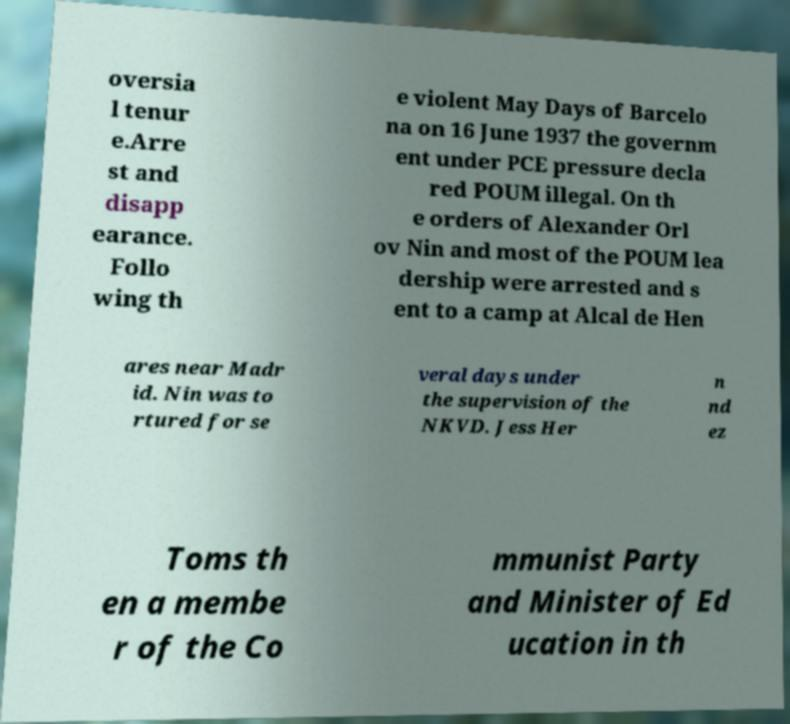Please identify and transcribe the text found in this image. oversia l tenur e.Arre st and disapp earance. Follo wing th e violent May Days of Barcelo na on 16 June 1937 the governm ent under PCE pressure decla red POUM illegal. On th e orders of Alexander Orl ov Nin and most of the POUM lea dership were arrested and s ent to a camp at Alcal de Hen ares near Madr id. Nin was to rtured for se veral days under the supervision of the NKVD. Jess Her n nd ez Toms th en a membe r of the Co mmunist Party and Minister of Ed ucation in th 